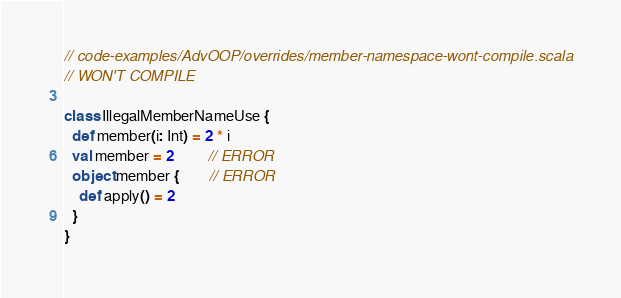<code> <loc_0><loc_0><loc_500><loc_500><_Scala_>// code-examples/AdvOOP/overrides/member-namespace-wont-compile.scala
// WON'T COMPILE

class IllegalMemberNameUse {
  def member(i: Int) = 2 * i
  val member = 2         // ERROR
  object member {        // ERROR 
    def apply() = 2
  }
}</code> 